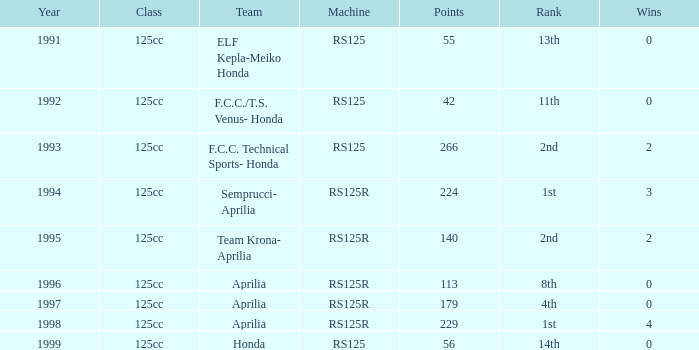What year featured an aprilia team with a 4th place standing? 1997.0. 